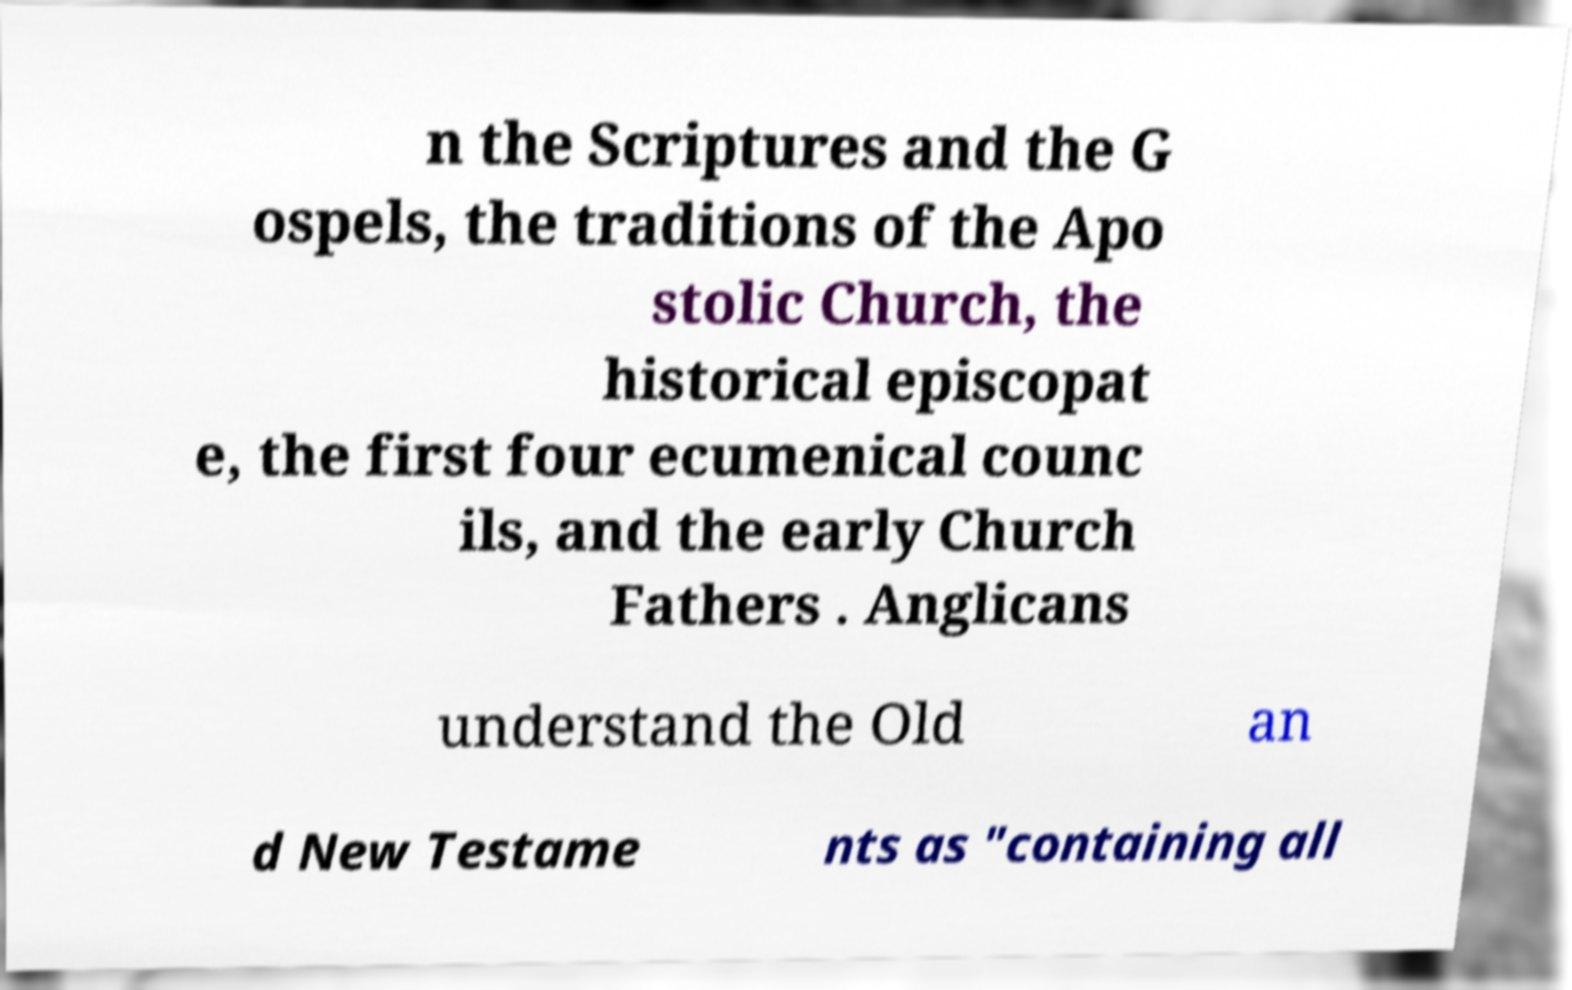Can you accurately transcribe the text from the provided image for me? n the Scriptures and the G ospels, the traditions of the Apo stolic Church, the historical episcopat e, the first four ecumenical counc ils, and the early Church Fathers . Anglicans understand the Old an d New Testame nts as "containing all 